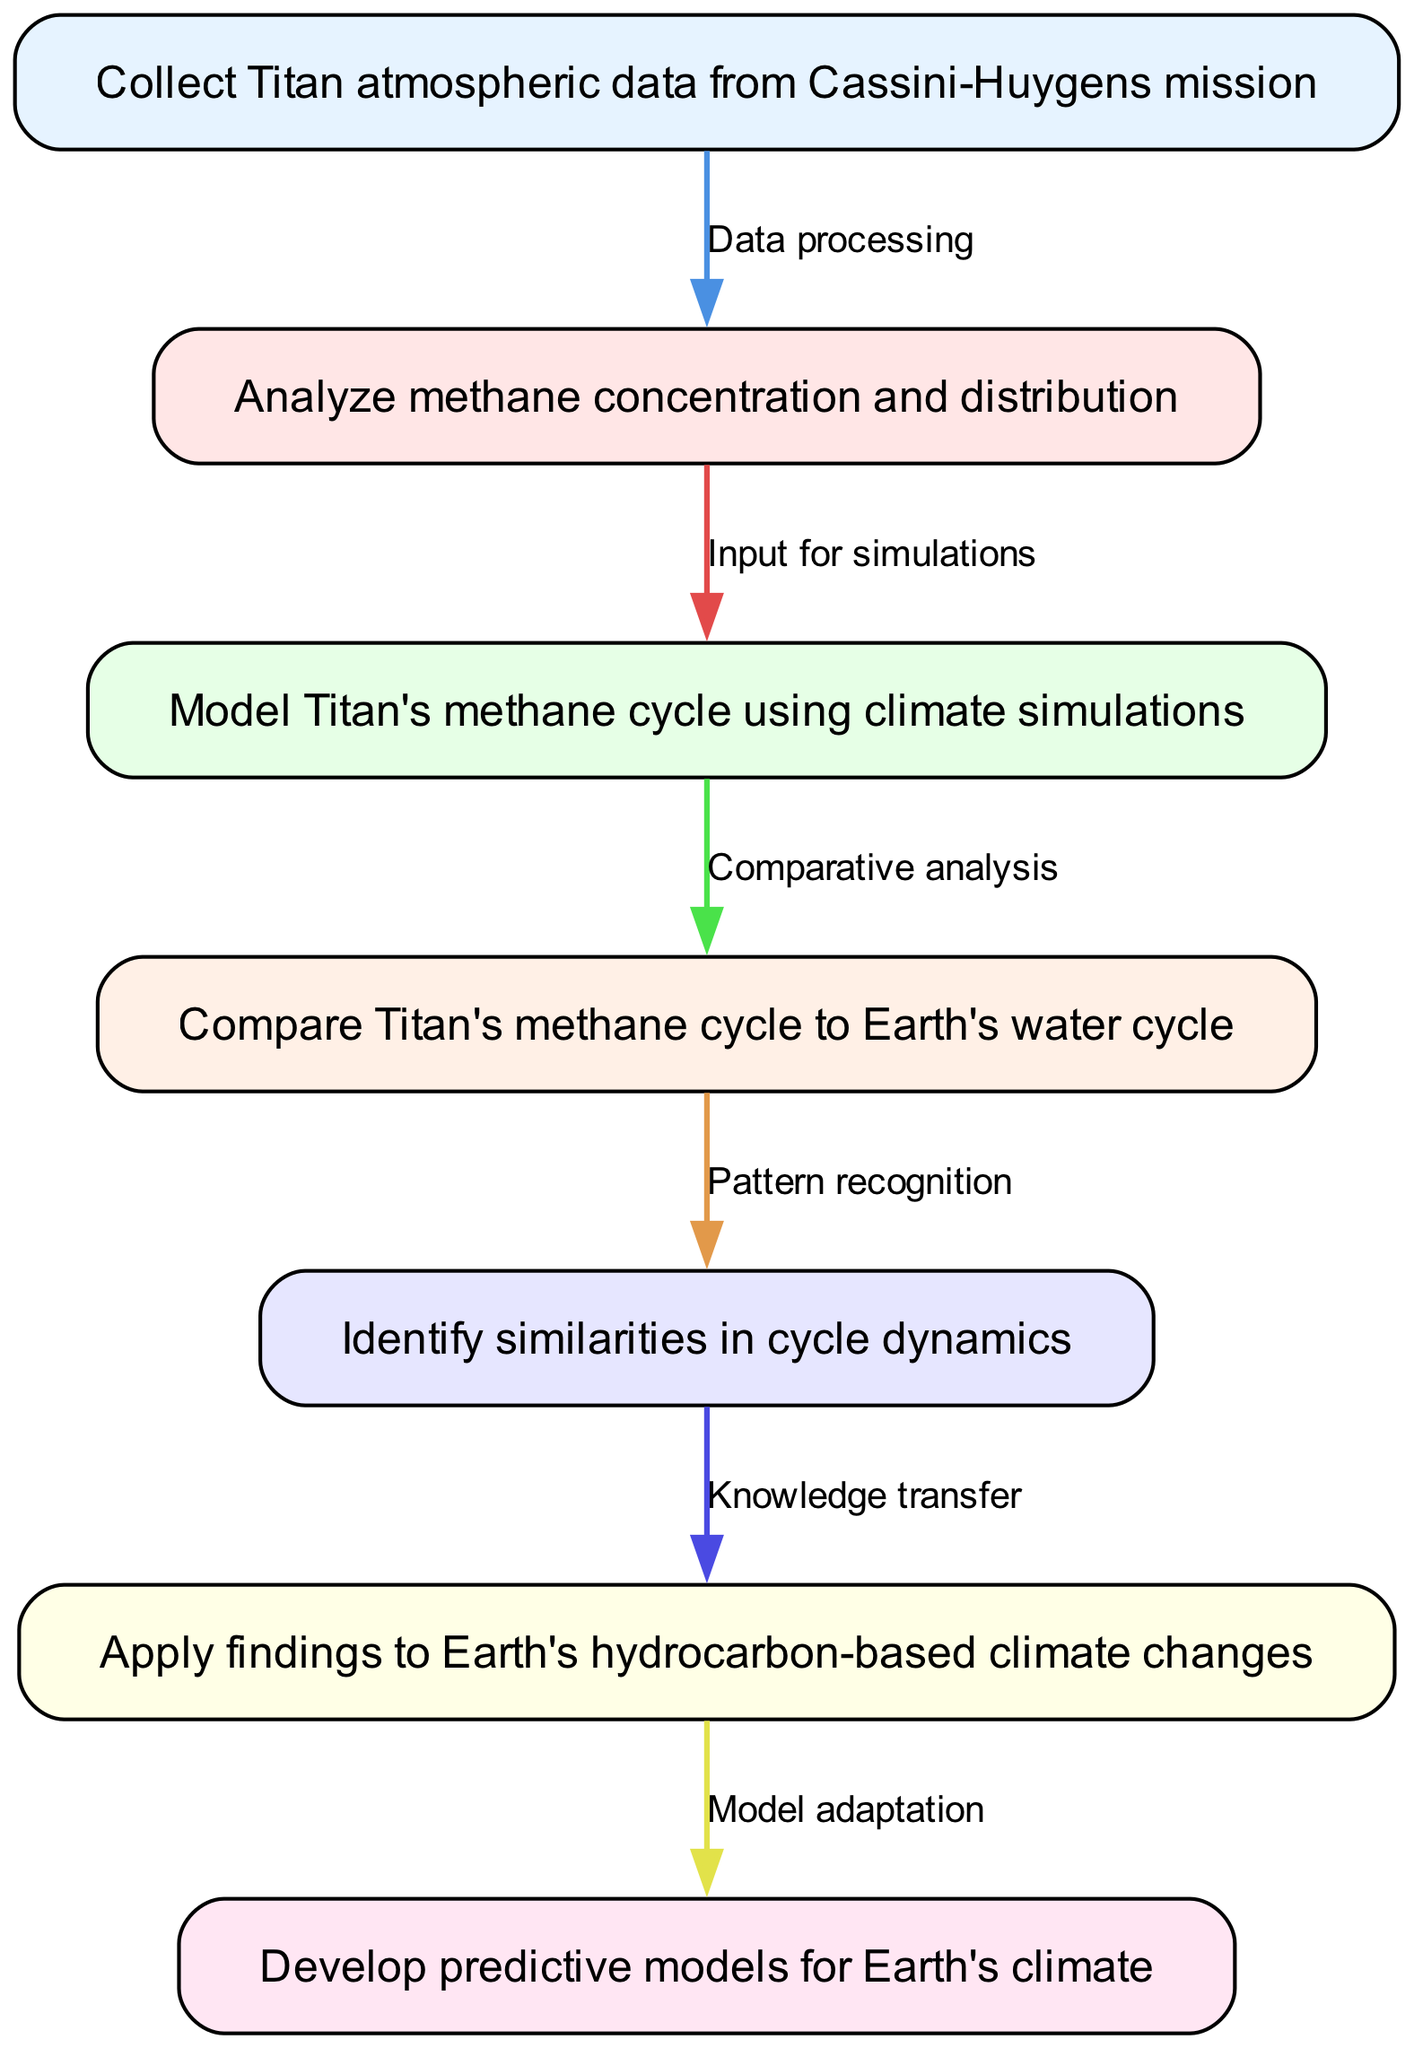What is the first step in the flowchart? The first node in the flowchart is "Collect Titan atmospheric data from Cassini-Huygens mission", which serves as the starting point for the analysis.
Answer: Collect Titan atmospheric data from Cassini-Huygens mission How many total nodes are in the diagram? The diagram contains 7 nodes, each representing a step in the analysis procedure.
Answer: 7 What is the relationship between nodes 2 and 3? The edge between node 2 ("Analyze methane concentration and distribution") and node 3 ("Model Titan's methane cycle using climate simulations") is labeled "Input for simulations", indicating that the analysis results feed into the simulations.
Answer: Input for simulations Which node involves the transfer of knowledge to Earth's climate? The node "Apply findings to Earth's hydrocarbon-based climate changes" indicates that the insights gathered from Titan's methane cycle are applied to understand climate changes on Earth.
Answer: Apply findings to Earth's hydrocarbon-based climate changes What is the final step in the procedure? The last node is "Develop predictive models for Earth's climate," which signifies the end goal of the analysis procedure.
Answer: Develop predictive models for Earth's climate What is the significance of the edge labeled "Comparative analysis"? The edge labeled "Comparative analysis" connects nodes 3 and 4, and it signifies that the modeled data from Titan's methane cycle is being compared to the Earth's water cycle for deeper insights.
Answer: Comparative analysis What are the similarities being identified in the analysis? The step "Identify similarities in cycle dynamics" suggests that the procedure seeks to find common patterns or behaviors between Titan's methane cycle and Earth's water cycle.
Answer: Identify similarities in cycle dynamics How does node 6 build on the findings from previous steps? Node 6 ("Apply findings to Earth's hydrocarbon-based climate changes") uses the knowledge acquired from earlier nodes, especially the identified similarities between Titan's cycle and Earth's climate, to adapt the findings.
Answer: Apply findings to Earth's hydrocarbon-based climate changes What is the connecting action between modeling and comparative analysis? The edge labeled "Comparative analysis" connects node 3 ("Model Titan's methane cycle using climate simulations") to node 4 ("Compare Titan's methane cycle to Earth's water cycle"), indicating that the output of modelling is essential for comparison.
Answer: Comparative analysis 